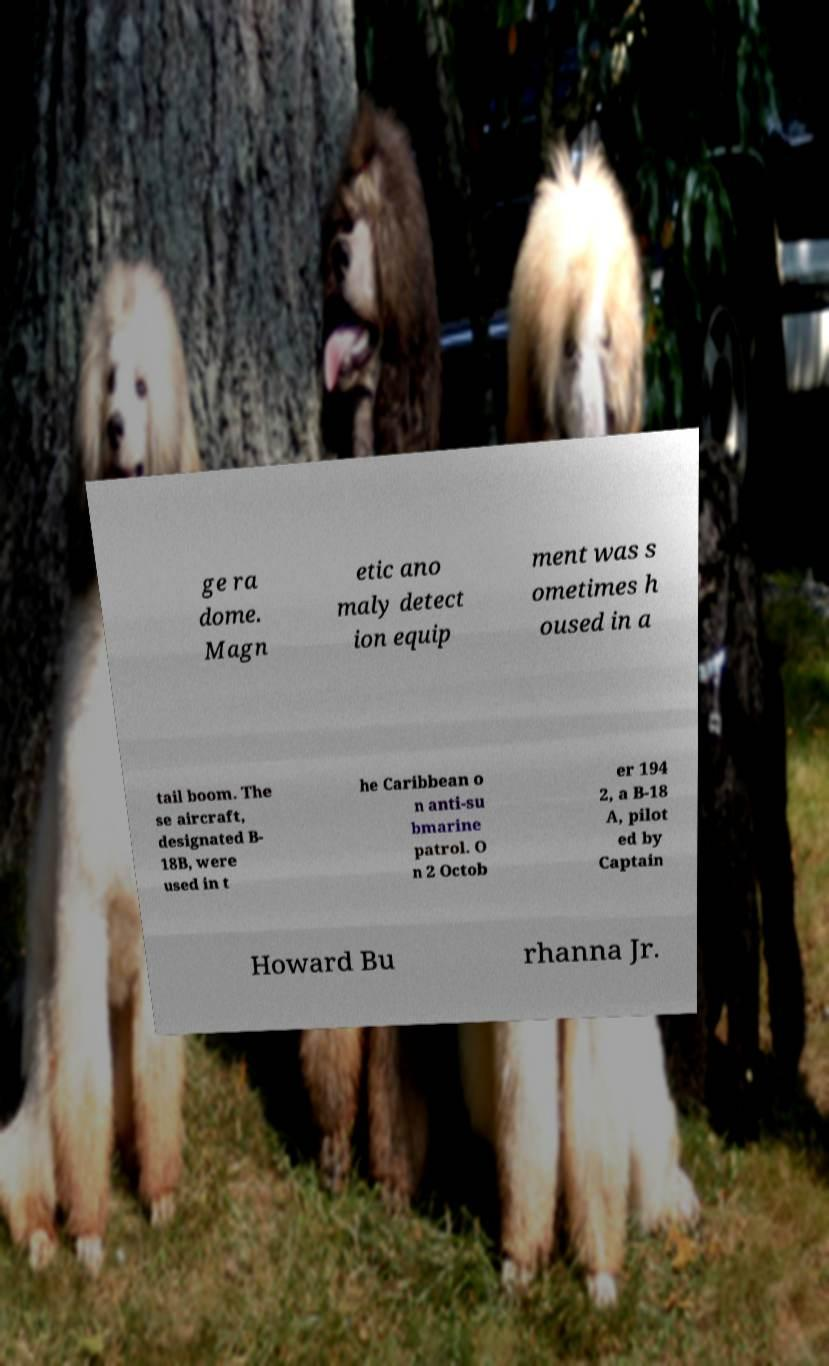Please read and relay the text visible in this image. What does it say? ge ra dome. Magn etic ano maly detect ion equip ment was s ometimes h oused in a tail boom. The se aircraft, designated B- 18B, were used in t he Caribbean o n anti-su bmarine patrol. O n 2 Octob er 194 2, a B-18 A, pilot ed by Captain Howard Bu rhanna Jr. 